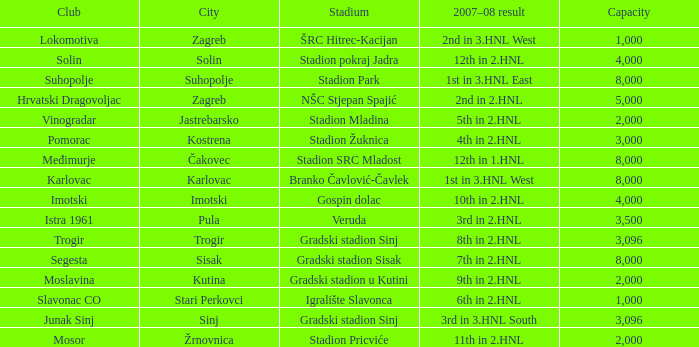What is the lowest capacity that has stadion mladina as the stadium? 2000.0. 